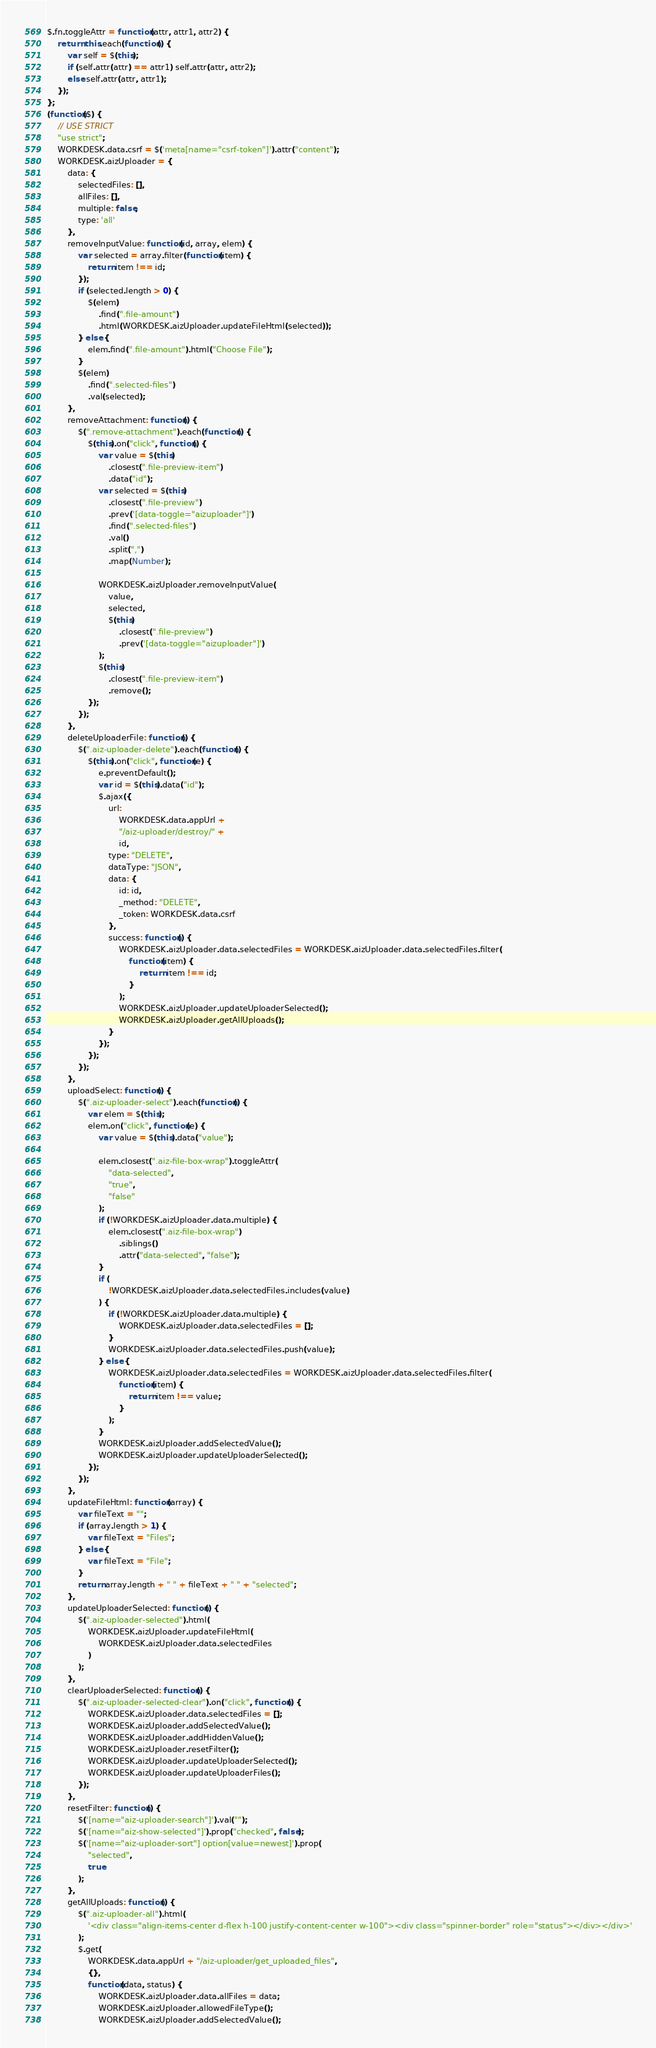Convert code to text. <code><loc_0><loc_0><loc_500><loc_500><_JavaScript_>$.fn.toggleAttr = function(attr, attr1, attr2) {
    return this.each(function() {
        var self = $(this);
        if (self.attr(attr) == attr1) self.attr(attr, attr2);
        else self.attr(attr, attr1);
    });
};
(function($) {
    // USE STRICT
    "use strict";
    WORKDESK.data.csrf = $('meta[name="csrf-token"]').attr("content");
    WORKDESK.aizUploader = {
        data: {
            selectedFiles: [],
            allFiles: [],
            multiple: false,
            type: 'all'
        },
        removeInputValue: function(id, array, elem) {
            var selected = array.filter(function(item) {
                return item !== id;
            });
            if (selected.length > 0) {
                $(elem)
                    .find(".file-amount")
                    .html(WORKDESK.aizUploader.updateFileHtml(selected));
            } else {
                elem.find(".file-amount").html("Choose File");
            }
            $(elem)
                .find(".selected-files")
                .val(selected);
        },
        removeAttachment: function() {
            $(".remove-attachment").each(function() {
                $(this).on("click", function() {
                    var value = $(this)
                        .closest(".file-preview-item")
                        .data("id");
                    var selected = $(this)
                        .closest(".file-preview")
                        .prev('[data-toggle="aizuploader"]')
                        .find(".selected-files")
                        .val()
                        .split(",")
                        .map(Number);

                    WORKDESK.aizUploader.removeInputValue(
                        value,
                        selected,
                        $(this)
                            .closest(".file-preview")
                            .prev('[data-toggle="aizuploader"]')
                    );
                    $(this)
                        .closest(".file-preview-item")
                        .remove();
                });
            });
        },
        deleteUploaderFile: function() {
            $(".aiz-uploader-delete").each(function() {
                $(this).on("click", function(e) {
                    e.preventDefault();
                    var id = $(this).data("id");
                    $.ajax({
                        url:
                            WORKDESK.data.appUrl +
                            "/aiz-uploader/destroy/" +
                            id,
                        type: "DELETE",
                        dataType: "JSON",
                        data: {
                            id: id,
                            _method: "DELETE",
                            _token: WORKDESK.data.csrf
                        },
                        success: function() {
                            WORKDESK.aizUploader.data.selectedFiles = WORKDESK.aizUploader.data.selectedFiles.filter(
                                function(item) {
                                    return item !== id;
                                }
                            );
                            WORKDESK.aizUploader.updateUploaderSelected();
                            WORKDESK.aizUploader.getAllUploads();
                        }
                    });
                });
            });
        },
        uploadSelect: function() {
            $(".aiz-uploader-select").each(function() {
                var elem = $(this);
                elem.on("click", function(e) {
                    var value = $(this).data("value");

                    elem.closest(".aiz-file-box-wrap").toggleAttr(
                        "data-selected",
                        "true",
                        "false"
                    );
                    if (!WORKDESK.aizUploader.data.multiple) {
                        elem.closest(".aiz-file-box-wrap")
                            .siblings()
                            .attr("data-selected", "false");
                    }
                    if (
                        !WORKDESK.aizUploader.data.selectedFiles.includes(value)
                    ) {
                        if (!WORKDESK.aizUploader.data.multiple) {
                            WORKDESK.aizUploader.data.selectedFiles = [];
                        }
                        WORKDESK.aizUploader.data.selectedFiles.push(value);
                    } else {
                        WORKDESK.aizUploader.data.selectedFiles = WORKDESK.aizUploader.data.selectedFiles.filter(
                            function(item) {
                                return item !== value;
                            }
                        );
                    }
                    WORKDESK.aizUploader.addSelectedValue();
                    WORKDESK.aizUploader.updateUploaderSelected();
                });
            });
        },
        updateFileHtml: function(array) {
            var fileText = "";
            if (array.length > 1) {
                var fileText = "Files";
            } else {
                var fileText = "File";
            }
            return array.length + " " + fileText + " " + "selected";
        },
        updateUploaderSelected: function() {
            $(".aiz-uploader-selected").html(
                WORKDESK.aizUploader.updateFileHtml(
                    WORKDESK.aizUploader.data.selectedFiles
                )
            );
        },
        clearUploaderSelected: function() {
            $(".aiz-uploader-selected-clear").on("click", function() {
                WORKDESK.aizUploader.data.selectedFiles = [];
                WORKDESK.aizUploader.addSelectedValue();
                WORKDESK.aizUploader.addHiddenValue();
                WORKDESK.aizUploader.resetFilter();
                WORKDESK.aizUploader.updateUploaderSelected();
                WORKDESK.aizUploader.updateUploaderFiles();
            });
        },
        resetFilter: function() {
            $('[name="aiz-uploader-search"]').val("");
            $('[name="aiz-show-selected"]').prop("checked", false);
            $('[name="aiz-uploader-sort"] option[value=newest]').prop(
                "selected",
                true
            );
        },
        getAllUploads: function() {
            $(".aiz-uploader-all").html(
                '<div class="align-items-center d-flex h-100 justify-content-center w-100"><div class="spinner-border" role="status"></div></div>'
            );
            $.get(
                WORKDESK.data.appUrl + "/aiz-uploader/get_uploaded_files",
                {},
                function(data, status) {
                    WORKDESK.aizUploader.data.allFiles = data;
                    WORKDESK.aizUploader.allowedFileType();
                    WORKDESK.aizUploader.addSelectedValue();</code> 